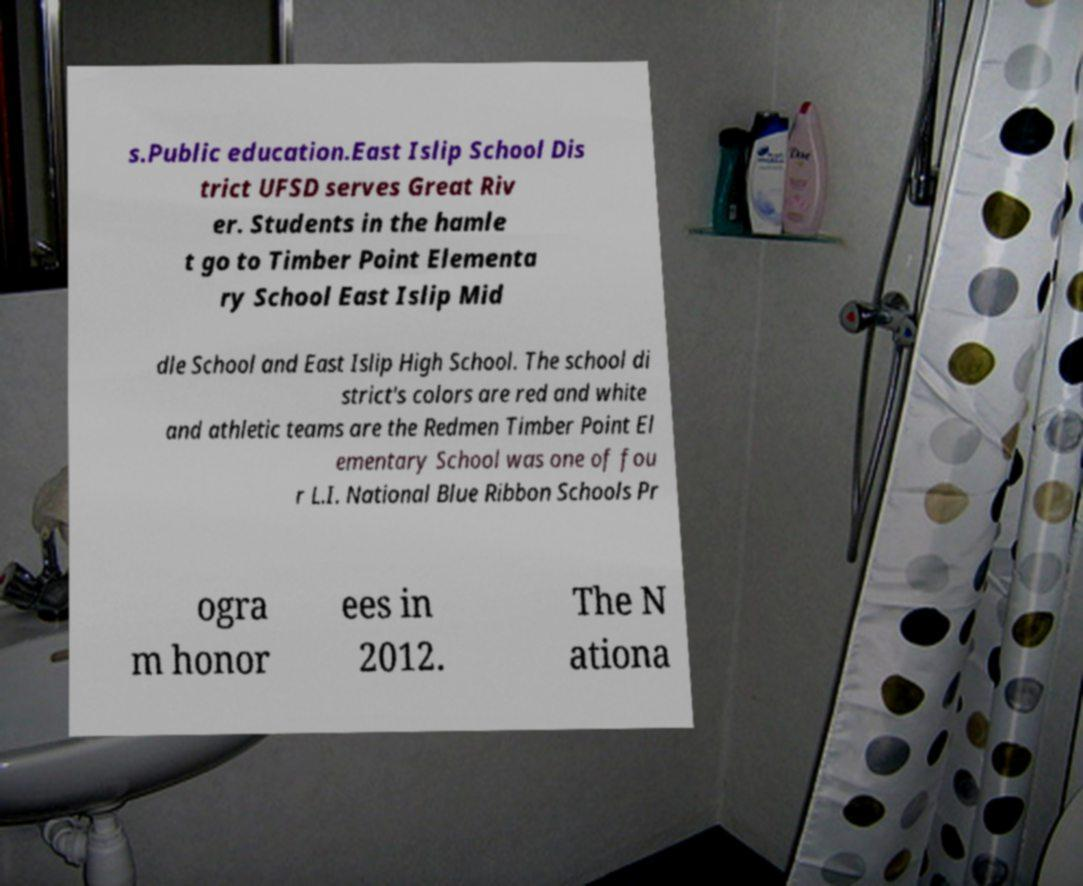Can you accurately transcribe the text from the provided image for me? s.Public education.East Islip School Dis trict UFSD serves Great Riv er. Students in the hamle t go to Timber Point Elementa ry School East Islip Mid dle School and East Islip High School. The school di strict's colors are red and white and athletic teams are the Redmen Timber Point El ementary School was one of fou r L.I. National Blue Ribbon Schools Pr ogra m honor ees in 2012. The N ationa 